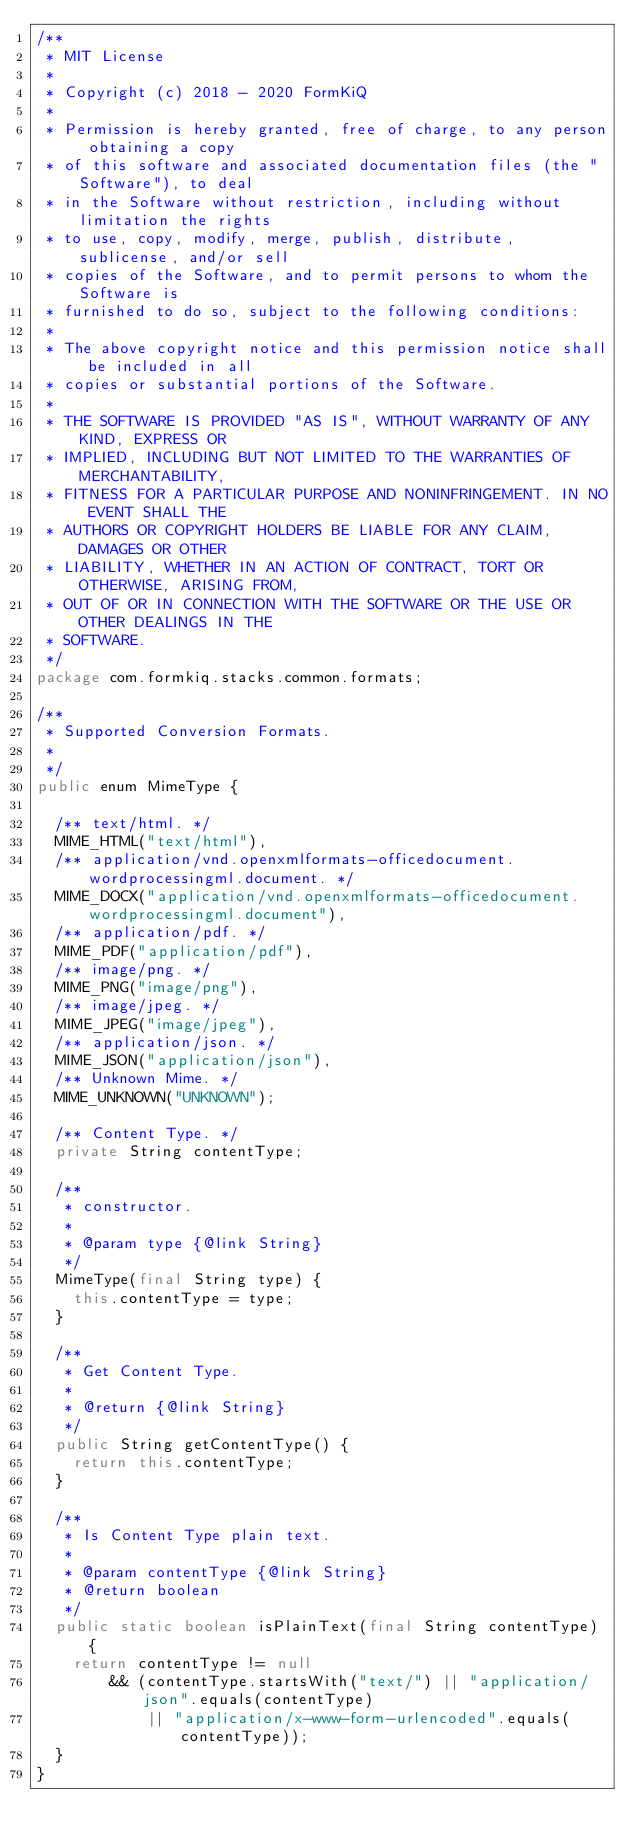Convert code to text. <code><loc_0><loc_0><loc_500><loc_500><_Java_>/**
 * MIT License
 * 
 * Copyright (c) 2018 - 2020 FormKiQ
 *
 * Permission is hereby granted, free of charge, to any person obtaining a copy
 * of this software and associated documentation files (the "Software"), to deal
 * in the Software without restriction, including without limitation the rights
 * to use, copy, modify, merge, publish, distribute, sublicense, and/or sell
 * copies of the Software, and to permit persons to whom the Software is
 * furnished to do so, subject to the following conditions:
 *
 * The above copyright notice and this permission notice shall be included in all
 * copies or substantial portions of the Software.
 * 
 * THE SOFTWARE IS PROVIDED "AS IS", WITHOUT WARRANTY OF ANY KIND, EXPRESS OR
 * IMPLIED, INCLUDING BUT NOT LIMITED TO THE WARRANTIES OF MERCHANTABILITY,
 * FITNESS FOR A PARTICULAR PURPOSE AND NONINFRINGEMENT. IN NO EVENT SHALL THE
 * AUTHORS OR COPYRIGHT HOLDERS BE LIABLE FOR ANY CLAIM, DAMAGES OR OTHER
 * LIABILITY, WHETHER IN AN ACTION OF CONTRACT, TORT OR OTHERWISE, ARISING FROM,
 * OUT OF OR IN CONNECTION WITH THE SOFTWARE OR THE USE OR OTHER DEALINGS IN THE
 * SOFTWARE.
 */
package com.formkiq.stacks.common.formats;

/**
 * Supported Conversion Formats.
 *
 */
public enum MimeType {

  /** text/html. */
  MIME_HTML("text/html"),
  /** application/vnd.openxmlformats-officedocument.wordprocessingml.document. */
  MIME_DOCX("application/vnd.openxmlformats-officedocument.wordprocessingml.document"),
  /** application/pdf. */
  MIME_PDF("application/pdf"),
  /** image/png. */
  MIME_PNG("image/png"),
  /** image/jpeg. */
  MIME_JPEG("image/jpeg"),
  /** application/json. */
  MIME_JSON("application/json"),
  /** Unknown Mime. */
  MIME_UNKNOWN("UNKNOWN");

  /** Content Type. */
  private String contentType;

  /**
   * constructor.
   * 
   * @param type {@link String}
   */
  MimeType(final String type) {
    this.contentType = type;
  }

  /**
   * Get Content Type.
   * 
   * @return {@link String}
   */
  public String getContentType() {
    return this.contentType;
  }
  
  /**
   * Is Content Type plain text.
   * 
   * @param contentType {@link String}
   * @return boolean
   */
  public static boolean isPlainText(final String contentType) {
    return contentType != null
        && (contentType.startsWith("text/") || "application/json".equals(contentType)
            || "application/x-www-form-urlencoded".equals(contentType));
  }
}
</code> 